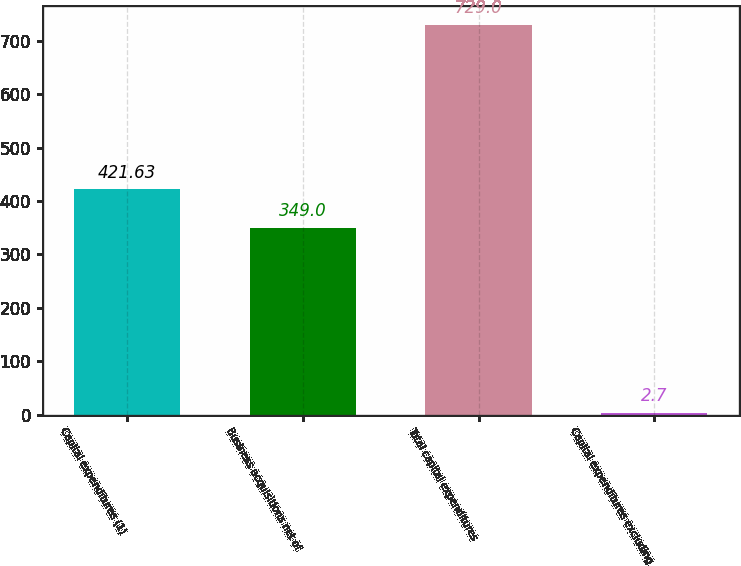Convert chart to OTSL. <chart><loc_0><loc_0><loc_500><loc_500><bar_chart><fcel>Capital expenditures (1)<fcel>Business acquisitions net of<fcel>Total capital expenditures<fcel>Capital expenditures excluding<nl><fcel>421.63<fcel>349<fcel>729<fcel>2.7<nl></chart> 